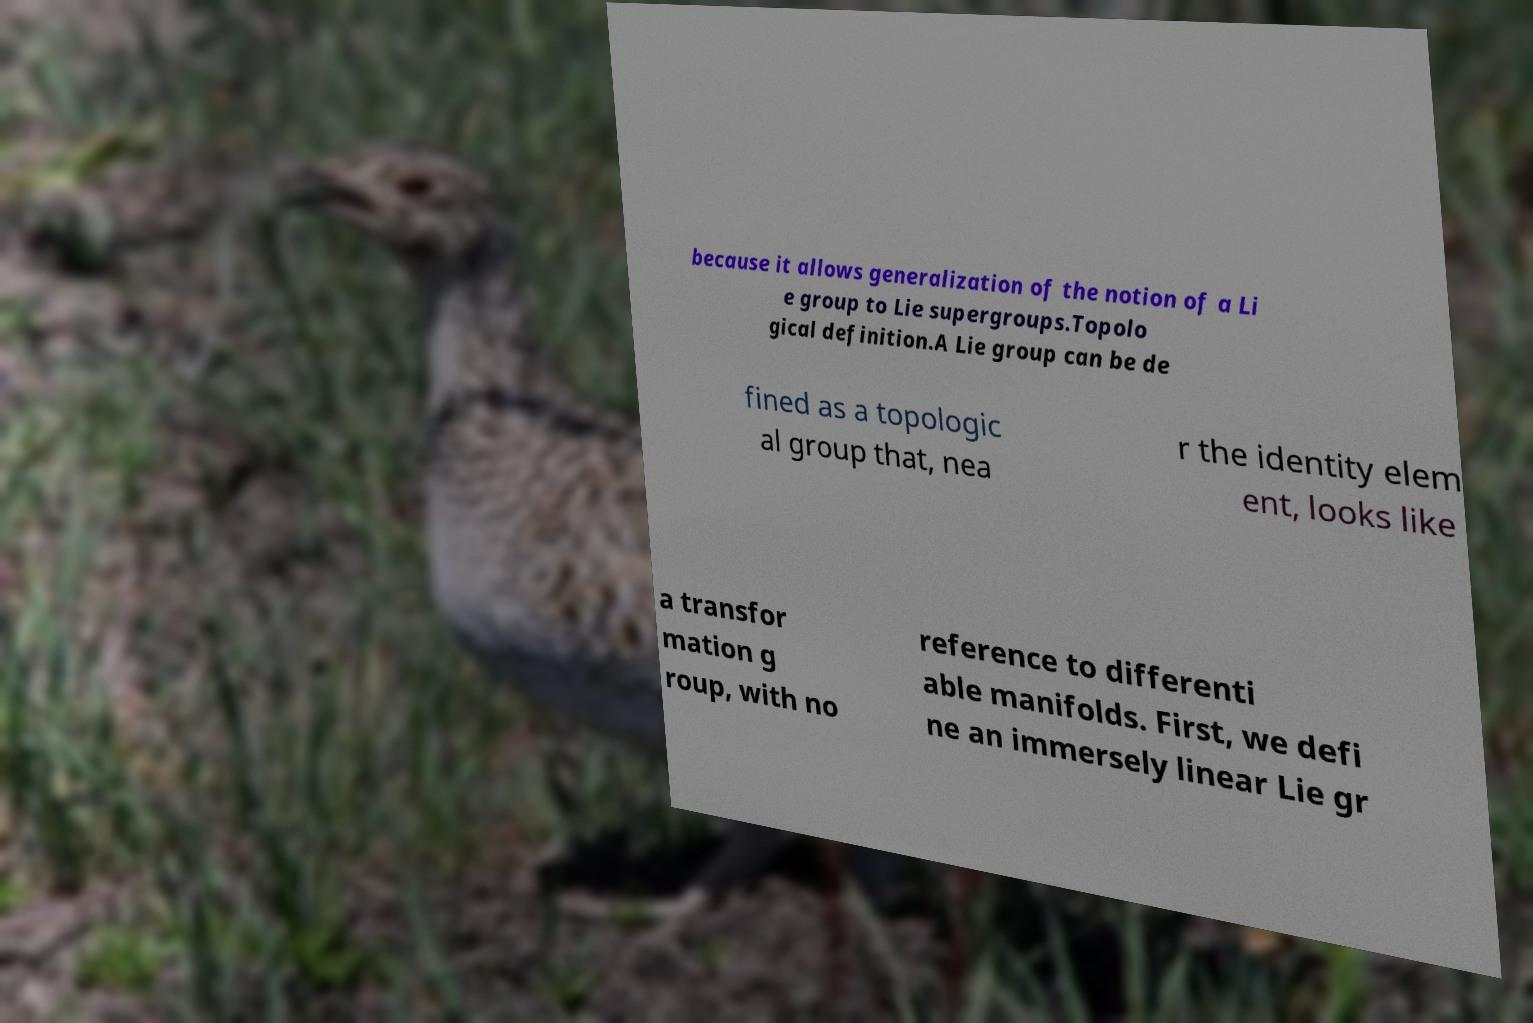What messages or text are displayed in this image? I need them in a readable, typed format. because it allows generalization of the notion of a Li e group to Lie supergroups.Topolo gical definition.A Lie group can be de fined as a topologic al group that, nea r the identity elem ent, looks like a transfor mation g roup, with no reference to differenti able manifolds. First, we defi ne an immersely linear Lie gr 